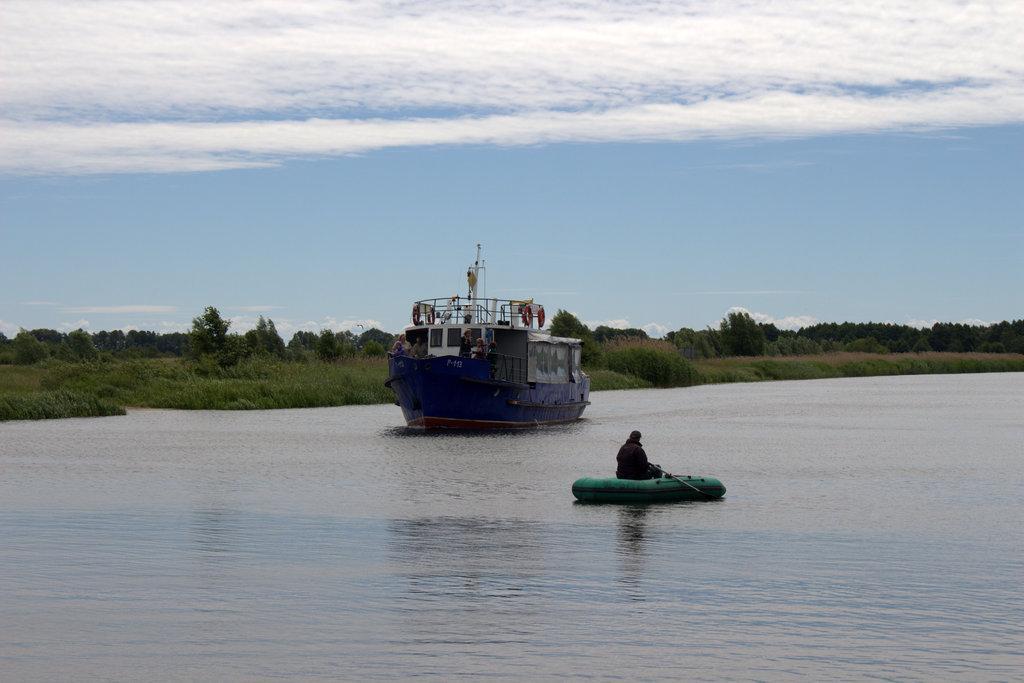Can you describe this image briefly? In this image, we can see boats floating on the water. There are some plants in the middle of the image. There is a sky at the top of the image. 